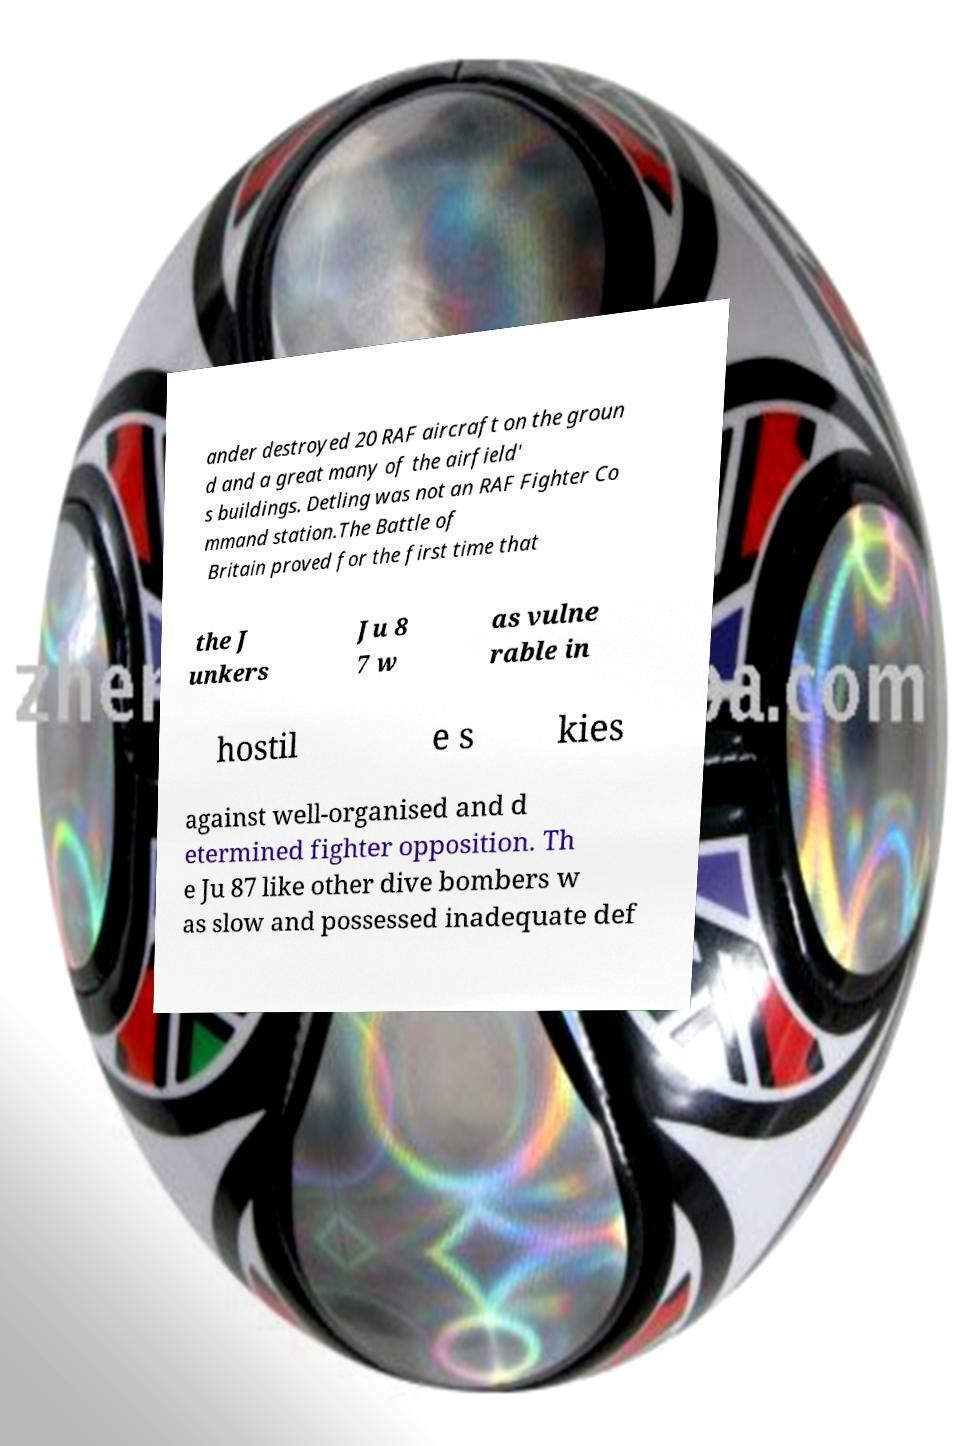What messages or text are displayed in this image? I need them in a readable, typed format. ander destroyed 20 RAF aircraft on the groun d and a great many of the airfield' s buildings. Detling was not an RAF Fighter Co mmand station.The Battle of Britain proved for the first time that the J unkers Ju 8 7 w as vulne rable in hostil e s kies against well-organised and d etermined fighter opposition. Th e Ju 87 like other dive bombers w as slow and possessed inadequate def 